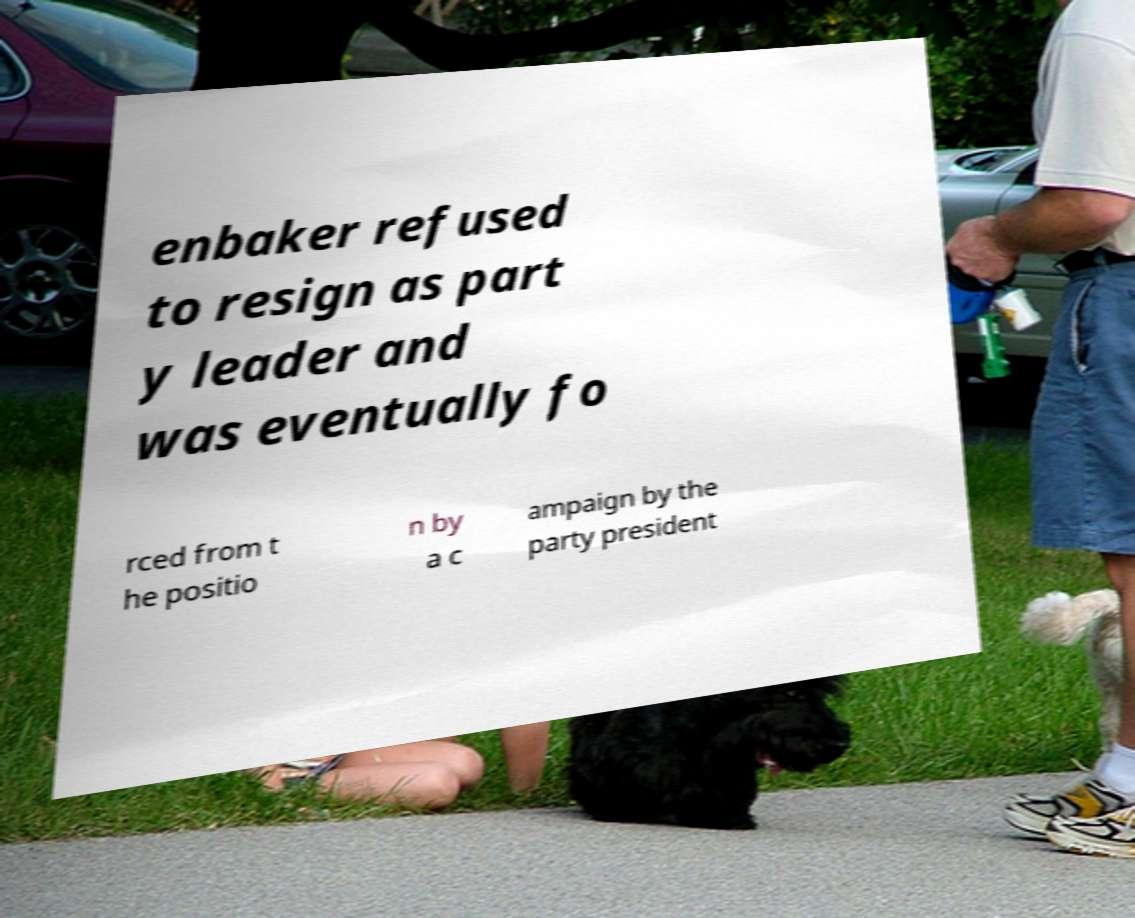Could you assist in decoding the text presented in this image and type it out clearly? enbaker refused to resign as part y leader and was eventually fo rced from t he positio n by a c ampaign by the party president 